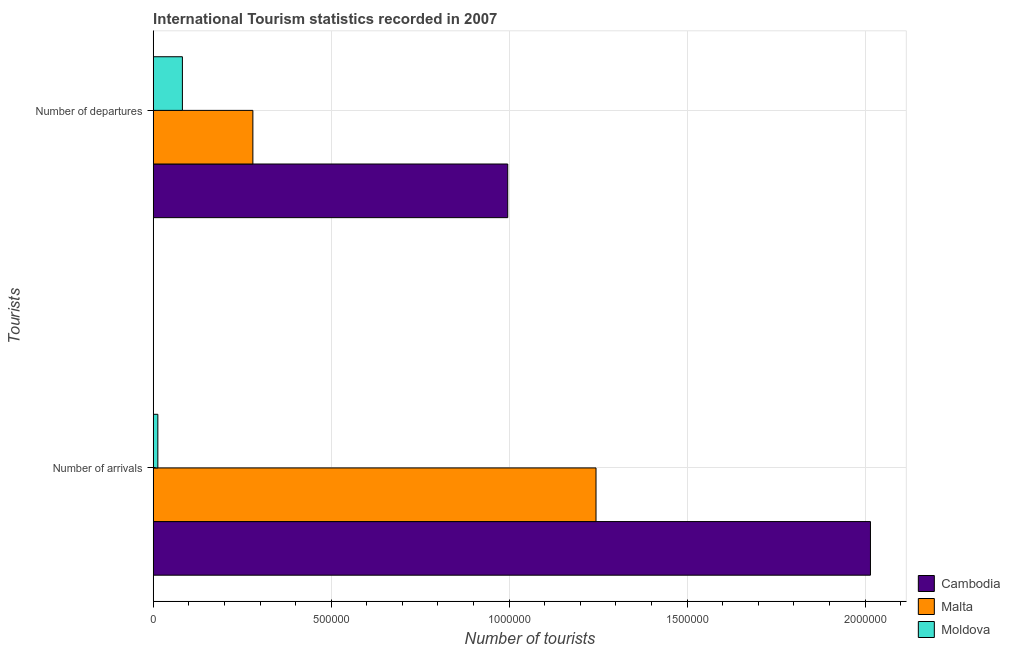How many different coloured bars are there?
Offer a very short reply. 3. Are the number of bars per tick equal to the number of legend labels?
Ensure brevity in your answer.  Yes. What is the label of the 1st group of bars from the top?
Your answer should be very brief. Number of departures. What is the number of tourist arrivals in Moldova?
Make the answer very short. 1.30e+04. Across all countries, what is the maximum number of tourist departures?
Ensure brevity in your answer.  9.96e+05. Across all countries, what is the minimum number of tourist departures?
Make the answer very short. 8.20e+04. In which country was the number of tourist departures maximum?
Your answer should be compact. Cambodia. In which country was the number of tourist departures minimum?
Your answer should be very brief. Moldova. What is the total number of tourist arrivals in the graph?
Provide a succinct answer. 3.27e+06. What is the difference between the number of tourist arrivals in Moldova and that in Cambodia?
Your response must be concise. -2.00e+06. What is the difference between the number of tourist departures in Cambodia and the number of tourist arrivals in Moldova?
Your response must be concise. 9.83e+05. What is the average number of tourist departures per country?
Ensure brevity in your answer.  4.53e+05. What is the difference between the number of tourist arrivals and number of tourist departures in Cambodia?
Give a very brief answer. 1.02e+06. What is the ratio of the number of tourist departures in Cambodia to that in Malta?
Ensure brevity in your answer.  3.56. What does the 1st bar from the top in Number of departures represents?
Make the answer very short. Moldova. What does the 1st bar from the bottom in Number of arrivals represents?
Offer a very short reply. Cambodia. How many bars are there?
Make the answer very short. 6. How many countries are there in the graph?
Offer a very short reply. 3. What is the difference between two consecutive major ticks on the X-axis?
Provide a short and direct response. 5.00e+05. Are the values on the major ticks of X-axis written in scientific E-notation?
Your answer should be compact. No. Does the graph contain any zero values?
Make the answer very short. No. Does the graph contain grids?
Keep it short and to the point. Yes. Where does the legend appear in the graph?
Provide a short and direct response. Bottom right. How many legend labels are there?
Your response must be concise. 3. What is the title of the graph?
Offer a very short reply. International Tourism statistics recorded in 2007. What is the label or title of the X-axis?
Give a very brief answer. Number of tourists. What is the label or title of the Y-axis?
Give a very brief answer. Tourists. What is the Number of tourists of Cambodia in Number of arrivals?
Your answer should be very brief. 2.02e+06. What is the Number of tourists in Malta in Number of arrivals?
Your answer should be compact. 1.24e+06. What is the Number of tourists in Moldova in Number of arrivals?
Keep it short and to the point. 1.30e+04. What is the Number of tourists in Cambodia in Number of departures?
Ensure brevity in your answer.  9.96e+05. What is the Number of tourists of Malta in Number of departures?
Your answer should be compact. 2.80e+05. What is the Number of tourists of Moldova in Number of departures?
Provide a short and direct response. 8.20e+04. Across all Tourists, what is the maximum Number of tourists in Cambodia?
Ensure brevity in your answer.  2.02e+06. Across all Tourists, what is the maximum Number of tourists in Malta?
Provide a short and direct response. 1.24e+06. Across all Tourists, what is the maximum Number of tourists of Moldova?
Keep it short and to the point. 8.20e+04. Across all Tourists, what is the minimum Number of tourists of Cambodia?
Your answer should be very brief. 9.96e+05. Across all Tourists, what is the minimum Number of tourists in Malta?
Keep it short and to the point. 2.80e+05. Across all Tourists, what is the minimum Number of tourists of Moldova?
Keep it short and to the point. 1.30e+04. What is the total Number of tourists in Cambodia in the graph?
Provide a short and direct response. 3.01e+06. What is the total Number of tourists of Malta in the graph?
Your answer should be compact. 1.52e+06. What is the total Number of tourists in Moldova in the graph?
Make the answer very short. 9.50e+04. What is the difference between the Number of tourists of Cambodia in Number of arrivals and that in Number of departures?
Ensure brevity in your answer.  1.02e+06. What is the difference between the Number of tourists in Malta in Number of arrivals and that in Number of departures?
Make the answer very short. 9.64e+05. What is the difference between the Number of tourists of Moldova in Number of arrivals and that in Number of departures?
Give a very brief answer. -6.90e+04. What is the difference between the Number of tourists of Cambodia in Number of arrivals and the Number of tourists of Malta in Number of departures?
Your response must be concise. 1.74e+06. What is the difference between the Number of tourists of Cambodia in Number of arrivals and the Number of tourists of Moldova in Number of departures?
Keep it short and to the point. 1.93e+06. What is the difference between the Number of tourists in Malta in Number of arrivals and the Number of tourists in Moldova in Number of departures?
Provide a short and direct response. 1.16e+06. What is the average Number of tourists of Cambodia per Tourists?
Give a very brief answer. 1.51e+06. What is the average Number of tourists of Malta per Tourists?
Provide a short and direct response. 7.62e+05. What is the average Number of tourists of Moldova per Tourists?
Your answer should be very brief. 4.75e+04. What is the difference between the Number of tourists of Cambodia and Number of tourists of Malta in Number of arrivals?
Offer a terse response. 7.71e+05. What is the difference between the Number of tourists in Cambodia and Number of tourists in Moldova in Number of arrivals?
Keep it short and to the point. 2.00e+06. What is the difference between the Number of tourists of Malta and Number of tourists of Moldova in Number of arrivals?
Provide a succinct answer. 1.23e+06. What is the difference between the Number of tourists in Cambodia and Number of tourists in Malta in Number of departures?
Offer a terse response. 7.16e+05. What is the difference between the Number of tourists in Cambodia and Number of tourists in Moldova in Number of departures?
Give a very brief answer. 9.14e+05. What is the difference between the Number of tourists in Malta and Number of tourists in Moldova in Number of departures?
Make the answer very short. 1.98e+05. What is the ratio of the Number of tourists of Cambodia in Number of arrivals to that in Number of departures?
Give a very brief answer. 2.02. What is the ratio of the Number of tourists of Malta in Number of arrivals to that in Number of departures?
Give a very brief answer. 4.44. What is the ratio of the Number of tourists in Moldova in Number of arrivals to that in Number of departures?
Provide a short and direct response. 0.16. What is the difference between the highest and the second highest Number of tourists in Cambodia?
Provide a short and direct response. 1.02e+06. What is the difference between the highest and the second highest Number of tourists in Malta?
Provide a short and direct response. 9.64e+05. What is the difference between the highest and the second highest Number of tourists of Moldova?
Offer a terse response. 6.90e+04. What is the difference between the highest and the lowest Number of tourists of Cambodia?
Your answer should be very brief. 1.02e+06. What is the difference between the highest and the lowest Number of tourists in Malta?
Your response must be concise. 9.64e+05. What is the difference between the highest and the lowest Number of tourists of Moldova?
Keep it short and to the point. 6.90e+04. 